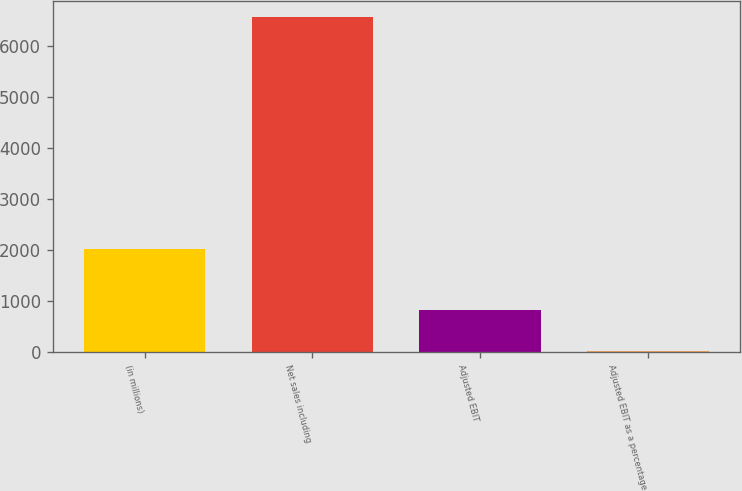Convert chart to OTSL. <chart><loc_0><loc_0><loc_500><loc_500><bar_chart><fcel>(in millions)<fcel>Net sales including<fcel>Adjusted EBIT<fcel>Adjusted EBIT as a percentage<nl><fcel>2019<fcel>6566.7<fcel>817.2<fcel>12.4<nl></chart> 